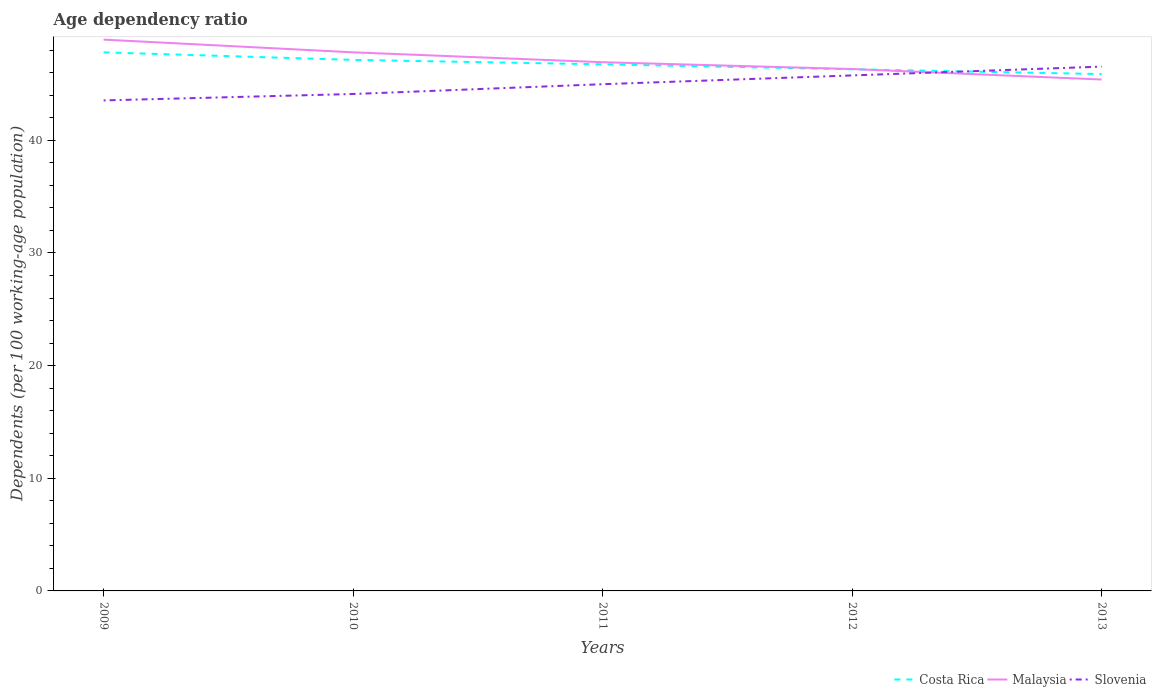Does the line corresponding to Malaysia intersect with the line corresponding to Costa Rica?
Provide a succinct answer. Yes. Across all years, what is the maximum age dependency ratio in in Costa Rica?
Give a very brief answer. 45.88. What is the total age dependency ratio in in Costa Rica in the graph?
Offer a very short reply. 0.43. What is the difference between the highest and the second highest age dependency ratio in in Costa Rica?
Ensure brevity in your answer.  1.93. Are the values on the major ticks of Y-axis written in scientific E-notation?
Make the answer very short. No. Does the graph contain any zero values?
Give a very brief answer. No. Where does the legend appear in the graph?
Provide a succinct answer. Bottom right. How are the legend labels stacked?
Give a very brief answer. Horizontal. What is the title of the graph?
Offer a very short reply. Age dependency ratio. Does "French Polynesia" appear as one of the legend labels in the graph?
Ensure brevity in your answer.  No. What is the label or title of the Y-axis?
Ensure brevity in your answer.  Dependents (per 100 working-age population). What is the Dependents (per 100 working-age population) in Costa Rica in 2009?
Keep it short and to the point. 47.81. What is the Dependents (per 100 working-age population) of Malaysia in 2009?
Your response must be concise. 48.94. What is the Dependents (per 100 working-age population) in Slovenia in 2009?
Keep it short and to the point. 43.54. What is the Dependents (per 100 working-age population) in Costa Rica in 2010?
Offer a very short reply. 47.14. What is the Dependents (per 100 working-age population) in Malaysia in 2010?
Your response must be concise. 47.81. What is the Dependents (per 100 working-age population) of Slovenia in 2010?
Your answer should be very brief. 44.11. What is the Dependents (per 100 working-age population) in Costa Rica in 2011?
Make the answer very short. 46.75. What is the Dependents (per 100 working-age population) in Malaysia in 2011?
Your answer should be compact. 46.93. What is the Dependents (per 100 working-age population) of Slovenia in 2011?
Offer a terse response. 44.98. What is the Dependents (per 100 working-age population) of Costa Rica in 2012?
Provide a succinct answer. 46.31. What is the Dependents (per 100 working-age population) of Malaysia in 2012?
Give a very brief answer. 46.33. What is the Dependents (per 100 working-age population) of Slovenia in 2012?
Provide a succinct answer. 45.76. What is the Dependents (per 100 working-age population) in Costa Rica in 2013?
Your response must be concise. 45.88. What is the Dependents (per 100 working-age population) of Malaysia in 2013?
Offer a terse response. 45.4. What is the Dependents (per 100 working-age population) in Slovenia in 2013?
Your answer should be very brief. 46.54. Across all years, what is the maximum Dependents (per 100 working-age population) in Costa Rica?
Your answer should be very brief. 47.81. Across all years, what is the maximum Dependents (per 100 working-age population) in Malaysia?
Ensure brevity in your answer.  48.94. Across all years, what is the maximum Dependents (per 100 working-age population) in Slovenia?
Your response must be concise. 46.54. Across all years, what is the minimum Dependents (per 100 working-age population) of Costa Rica?
Make the answer very short. 45.88. Across all years, what is the minimum Dependents (per 100 working-age population) of Malaysia?
Offer a terse response. 45.4. Across all years, what is the minimum Dependents (per 100 working-age population) of Slovenia?
Offer a terse response. 43.54. What is the total Dependents (per 100 working-age population) in Costa Rica in the graph?
Ensure brevity in your answer.  233.88. What is the total Dependents (per 100 working-age population) in Malaysia in the graph?
Ensure brevity in your answer.  235.4. What is the total Dependents (per 100 working-age population) of Slovenia in the graph?
Your answer should be very brief. 224.93. What is the difference between the Dependents (per 100 working-age population) of Costa Rica in 2009 and that in 2010?
Provide a succinct answer. 0.67. What is the difference between the Dependents (per 100 working-age population) of Malaysia in 2009 and that in 2010?
Your answer should be very brief. 1.13. What is the difference between the Dependents (per 100 working-age population) of Slovenia in 2009 and that in 2010?
Keep it short and to the point. -0.57. What is the difference between the Dependents (per 100 working-age population) in Costa Rica in 2009 and that in 2011?
Provide a succinct answer. 1.06. What is the difference between the Dependents (per 100 working-age population) of Malaysia in 2009 and that in 2011?
Keep it short and to the point. 2. What is the difference between the Dependents (per 100 working-age population) in Slovenia in 2009 and that in 2011?
Offer a terse response. -1.44. What is the difference between the Dependents (per 100 working-age population) in Costa Rica in 2009 and that in 2012?
Your response must be concise. 1.5. What is the difference between the Dependents (per 100 working-age population) of Malaysia in 2009 and that in 2012?
Ensure brevity in your answer.  2.61. What is the difference between the Dependents (per 100 working-age population) in Slovenia in 2009 and that in 2012?
Make the answer very short. -2.22. What is the difference between the Dependents (per 100 working-age population) in Costa Rica in 2009 and that in 2013?
Offer a terse response. 1.93. What is the difference between the Dependents (per 100 working-age population) of Malaysia in 2009 and that in 2013?
Your answer should be compact. 3.54. What is the difference between the Dependents (per 100 working-age population) of Slovenia in 2009 and that in 2013?
Provide a short and direct response. -3. What is the difference between the Dependents (per 100 working-age population) in Costa Rica in 2010 and that in 2011?
Make the answer very short. 0.39. What is the difference between the Dependents (per 100 working-age population) in Malaysia in 2010 and that in 2011?
Offer a terse response. 0.88. What is the difference between the Dependents (per 100 working-age population) of Slovenia in 2010 and that in 2011?
Provide a short and direct response. -0.87. What is the difference between the Dependents (per 100 working-age population) of Costa Rica in 2010 and that in 2012?
Give a very brief answer. 0.83. What is the difference between the Dependents (per 100 working-age population) of Malaysia in 2010 and that in 2012?
Your answer should be compact. 1.48. What is the difference between the Dependents (per 100 working-age population) in Slovenia in 2010 and that in 2012?
Offer a terse response. -1.65. What is the difference between the Dependents (per 100 working-age population) of Costa Rica in 2010 and that in 2013?
Your response must be concise. 1.26. What is the difference between the Dependents (per 100 working-age population) in Malaysia in 2010 and that in 2013?
Provide a short and direct response. 2.41. What is the difference between the Dependents (per 100 working-age population) in Slovenia in 2010 and that in 2013?
Offer a terse response. -2.43. What is the difference between the Dependents (per 100 working-age population) in Costa Rica in 2011 and that in 2012?
Offer a terse response. 0.44. What is the difference between the Dependents (per 100 working-age population) of Malaysia in 2011 and that in 2012?
Make the answer very short. 0.61. What is the difference between the Dependents (per 100 working-age population) of Slovenia in 2011 and that in 2012?
Offer a very short reply. -0.78. What is the difference between the Dependents (per 100 working-age population) in Costa Rica in 2011 and that in 2013?
Provide a succinct answer. 0.87. What is the difference between the Dependents (per 100 working-age population) in Malaysia in 2011 and that in 2013?
Keep it short and to the point. 1.54. What is the difference between the Dependents (per 100 working-age population) of Slovenia in 2011 and that in 2013?
Ensure brevity in your answer.  -1.56. What is the difference between the Dependents (per 100 working-age population) of Costa Rica in 2012 and that in 2013?
Ensure brevity in your answer.  0.43. What is the difference between the Dependents (per 100 working-age population) of Malaysia in 2012 and that in 2013?
Make the answer very short. 0.93. What is the difference between the Dependents (per 100 working-age population) of Slovenia in 2012 and that in 2013?
Provide a succinct answer. -0.78. What is the difference between the Dependents (per 100 working-age population) of Costa Rica in 2009 and the Dependents (per 100 working-age population) of Malaysia in 2010?
Your answer should be very brief. -0. What is the difference between the Dependents (per 100 working-age population) in Costa Rica in 2009 and the Dependents (per 100 working-age population) in Slovenia in 2010?
Provide a succinct answer. 3.7. What is the difference between the Dependents (per 100 working-age population) of Malaysia in 2009 and the Dependents (per 100 working-age population) of Slovenia in 2010?
Your answer should be compact. 4.83. What is the difference between the Dependents (per 100 working-age population) in Costa Rica in 2009 and the Dependents (per 100 working-age population) in Malaysia in 2011?
Offer a very short reply. 0.88. What is the difference between the Dependents (per 100 working-age population) of Costa Rica in 2009 and the Dependents (per 100 working-age population) of Slovenia in 2011?
Your response must be concise. 2.83. What is the difference between the Dependents (per 100 working-age population) of Malaysia in 2009 and the Dependents (per 100 working-age population) of Slovenia in 2011?
Your response must be concise. 3.96. What is the difference between the Dependents (per 100 working-age population) in Costa Rica in 2009 and the Dependents (per 100 working-age population) in Malaysia in 2012?
Your answer should be very brief. 1.48. What is the difference between the Dependents (per 100 working-age population) in Costa Rica in 2009 and the Dependents (per 100 working-age population) in Slovenia in 2012?
Provide a short and direct response. 2.05. What is the difference between the Dependents (per 100 working-age population) in Malaysia in 2009 and the Dependents (per 100 working-age population) in Slovenia in 2012?
Offer a terse response. 3.18. What is the difference between the Dependents (per 100 working-age population) of Costa Rica in 2009 and the Dependents (per 100 working-age population) of Malaysia in 2013?
Ensure brevity in your answer.  2.41. What is the difference between the Dependents (per 100 working-age population) in Costa Rica in 2009 and the Dependents (per 100 working-age population) in Slovenia in 2013?
Your response must be concise. 1.27. What is the difference between the Dependents (per 100 working-age population) of Malaysia in 2009 and the Dependents (per 100 working-age population) of Slovenia in 2013?
Provide a short and direct response. 2.4. What is the difference between the Dependents (per 100 working-age population) of Costa Rica in 2010 and the Dependents (per 100 working-age population) of Malaysia in 2011?
Provide a short and direct response. 0.21. What is the difference between the Dependents (per 100 working-age population) of Costa Rica in 2010 and the Dependents (per 100 working-age population) of Slovenia in 2011?
Give a very brief answer. 2.16. What is the difference between the Dependents (per 100 working-age population) in Malaysia in 2010 and the Dependents (per 100 working-age population) in Slovenia in 2011?
Offer a terse response. 2.83. What is the difference between the Dependents (per 100 working-age population) in Costa Rica in 2010 and the Dependents (per 100 working-age population) in Malaysia in 2012?
Your answer should be compact. 0.81. What is the difference between the Dependents (per 100 working-age population) in Costa Rica in 2010 and the Dependents (per 100 working-age population) in Slovenia in 2012?
Your answer should be very brief. 1.38. What is the difference between the Dependents (per 100 working-age population) of Malaysia in 2010 and the Dependents (per 100 working-age population) of Slovenia in 2012?
Offer a terse response. 2.05. What is the difference between the Dependents (per 100 working-age population) of Costa Rica in 2010 and the Dependents (per 100 working-age population) of Malaysia in 2013?
Provide a short and direct response. 1.74. What is the difference between the Dependents (per 100 working-age population) of Costa Rica in 2010 and the Dependents (per 100 working-age population) of Slovenia in 2013?
Your answer should be compact. 0.6. What is the difference between the Dependents (per 100 working-age population) of Malaysia in 2010 and the Dependents (per 100 working-age population) of Slovenia in 2013?
Make the answer very short. 1.27. What is the difference between the Dependents (per 100 working-age population) of Costa Rica in 2011 and the Dependents (per 100 working-age population) of Malaysia in 2012?
Offer a very short reply. 0.42. What is the difference between the Dependents (per 100 working-age population) of Costa Rica in 2011 and the Dependents (per 100 working-age population) of Slovenia in 2012?
Your answer should be compact. 0.99. What is the difference between the Dependents (per 100 working-age population) in Malaysia in 2011 and the Dependents (per 100 working-age population) in Slovenia in 2012?
Your answer should be very brief. 1.17. What is the difference between the Dependents (per 100 working-age population) of Costa Rica in 2011 and the Dependents (per 100 working-age population) of Malaysia in 2013?
Offer a terse response. 1.35. What is the difference between the Dependents (per 100 working-age population) of Costa Rica in 2011 and the Dependents (per 100 working-age population) of Slovenia in 2013?
Ensure brevity in your answer.  0.2. What is the difference between the Dependents (per 100 working-age population) in Malaysia in 2011 and the Dependents (per 100 working-age population) in Slovenia in 2013?
Make the answer very short. 0.39. What is the difference between the Dependents (per 100 working-age population) of Costa Rica in 2012 and the Dependents (per 100 working-age population) of Malaysia in 2013?
Offer a very short reply. 0.91. What is the difference between the Dependents (per 100 working-age population) in Costa Rica in 2012 and the Dependents (per 100 working-age population) in Slovenia in 2013?
Your answer should be very brief. -0.24. What is the difference between the Dependents (per 100 working-age population) in Malaysia in 2012 and the Dependents (per 100 working-age population) in Slovenia in 2013?
Ensure brevity in your answer.  -0.21. What is the average Dependents (per 100 working-age population) in Costa Rica per year?
Give a very brief answer. 46.78. What is the average Dependents (per 100 working-age population) of Malaysia per year?
Your answer should be very brief. 47.08. What is the average Dependents (per 100 working-age population) of Slovenia per year?
Your response must be concise. 44.99. In the year 2009, what is the difference between the Dependents (per 100 working-age population) in Costa Rica and Dependents (per 100 working-age population) in Malaysia?
Keep it short and to the point. -1.13. In the year 2009, what is the difference between the Dependents (per 100 working-age population) of Costa Rica and Dependents (per 100 working-age population) of Slovenia?
Offer a very short reply. 4.27. In the year 2009, what is the difference between the Dependents (per 100 working-age population) of Malaysia and Dependents (per 100 working-age population) of Slovenia?
Your answer should be compact. 5.4. In the year 2010, what is the difference between the Dependents (per 100 working-age population) of Costa Rica and Dependents (per 100 working-age population) of Malaysia?
Your answer should be very brief. -0.67. In the year 2010, what is the difference between the Dependents (per 100 working-age population) of Costa Rica and Dependents (per 100 working-age population) of Slovenia?
Provide a succinct answer. 3.03. In the year 2010, what is the difference between the Dependents (per 100 working-age population) of Malaysia and Dependents (per 100 working-age population) of Slovenia?
Your answer should be very brief. 3.7. In the year 2011, what is the difference between the Dependents (per 100 working-age population) in Costa Rica and Dependents (per 100 working-age population) in Malaysia?
Give a very brief answer. -0.19. In the year 2011, what is the difference between the Dependents (per 100 working-age population) in Costa Rica and Dependents (per 100 working-age population) in Slovenia?
Keep it short and to the point. 1.77. In the year 2011, what is the difference between the Dependents (per 100 working-age population) in Malaysia and Dependents (per 100 working-age population) in Slovenia?
Your answer should be very brief. 1.95. In the year 2012, what is the difference between the Dependents (per 100 working-age population) of Costa Rica and Dependents (per 100 working-age population) of Malaysia?
Offer a terse response. -0.02. In the year 2012, what is the difference between the Dependents (per 100 working-age population) in Costa Rica and Dependents (per 100 working-age population) in Slovenia?
Give a very brief answer. 0.55. In the year 2012, what is the difference between the Dependents (per 100 working-age population) of Malaysia and Dependents (per 100 working-age population) of Slovenia?
Make the answer very short. 0.57. In the year 2013, what is the difference between the Dependents (per 100 working-age population) in Costa Rica and Dependents (per 100 working-age population) in Malaysia?
Your response must be concise. 0.48. In the year 2013, what is the difference between the Dependents (per 100 working-age population) of Costa Rica and Dependents (per 100 working-age population) of Slovenia?
Offer a terse response. -0.66. In the year 2013, what is the difference between the Dependents (per 100 working-age population) in Malaysia and Dependents (per 100 working-age population) in Slovenia?
Offer a very short reply. -1.15. What is the ratio of the Dependents (per 100 working-age population) in Costa Rica in 2009 to that in 2010?
Your response must be concise. 1.01. What is the ratio of the Dependents (per 100 working-age population) of Malaysia in 2009 to that in 2010?
Keep it short and to the point. 1.02. What is the ratio of the Dependents (per 100 working-age population) in Slovenia in 2009 to that in 2010?
Give a very brief answer. 0.99. What is the ratio of the Dependents (per 100 working-age population) of Costa Rica in 2009 to that in 2011?
Make the answer very short. 1.02. What is the ratio of the Dependents (per 100 working-age population) of Malaysia in 2009 to that in 2011?
Give a very brief answer. 1.04. What is the ratio of the Dependents (per 100 working-age population) of Costa Rica in 2009 to that in 2012?
Ensure brevity in your answer.  1.03. What is the ratio of the Dependents (per 100 working-age population) in Malaysia in 2009 to that in 2012?
Your answer should be very brief. 1.06. What is the ratio of the Dependents (per 100 working-age population) in Slovenia in 2009 to that in 2012?
Offer a terse response. 0.95. What is the ratio of the Dependents (per 100 working-age population) of Costa Rica in 2009 to that in 2013?
Your response must be concise. 1.04. What is the ratio of the Dependents (per 100 working-age population) of Malaysia in 2009 to that in 2013?
Your response must be concise. 1.08. What is the ratio of the Dependents (per 100 working-age population) in Slovenia in 2009 to that in 2013?
Offer a terse response. 0.94. What is the ratio of the Dependents (per 100 working-age population) of Costa Rica in 2010 to that in 2011?
Provide a short and direct response. 1.01. What is the ratio of the Dependents (per 100 working-age population) in Malaysia in 2010 to that in 2011?
Provide a short and direct response. 1.02. What is the ratio of the Dependents (per 100 working-age population) in Slovenia in 2010 to that in 2011?
Ensure brevity in your answer.  0.98. What is the ratio of the Dependents (per 100 working-age population) of Costa Rica in 2010 to that in 2012?
Give a very brief answer. 1.02. What is the ratio of the Dependents (per 100 working-age population) of Malaysia in 2010 to that in 2012?
Provide a short and direct response. 1.03. What is the ratio of the Dependents (per 100 working-age population) in Slovenia in 2010 to that in 2012?
Give a very brief answer. 0.96. What is the ratio of the Dependents (per 100 working-age population) in Costa Rica in 2010 to that in 2013?
Offer a terse response. 1.03. What is the ratio of the Dependents (per 100 working-age population) of Malaysia in 2010 to that in 2013?
Offer a very short reply. 1.05. What is the ratio of the Dependents (per 100 working-age population) of Slovenia in 2010 to that in 2013?
Keep it short and to the point. 0.95. What is the ratio of the Dependents (per 100 working-age population) of Costa Rica in 2011 to that in 2012?
Offer a terse response. 1.01. What is the ratio of the Dependents (per 100 working-age population) in Malaysia in 2011 to that in 2012?
Give a very brief answer. 1.01. What is the ratio of the Dependents (per 100 working-age population) in Slovenia in 2011 to that in 2012?
Your answer should be very brief. 0.98. What is the ratio of the Dependents (per 100 working-age population) in Costa Rica in 2011 to that in 2013?
Make the answer very short. 1.02. What is the ratio of the Dependents (per 100 working-age population) of Malaysia in 2011 to that in 2013?
Your response must be concise. 1.03. What is the ratio of the Dependents (per 100 working-age population) in Slovenia in 2011 to that in 2013?
Your answer should be very brief. 0.97. What is the ratio of the Dependents (per 100 working-age population) of Costa Rica in 2012 to that in 2013?
Your response must be concise. 1.01. What is the ratio of the Dependents (per 100 working-age population) in Malaysia in 2012 to that in 2013?
Your answer should be very brief. 1.02. What is the ratio of the Dependents (per 100 working-age population) of Slovenia in 2012 to that in 2013?
Provide a short and direct response. 0.98. What is the difference between the highest and the second highest Dependents (per 100 working-age population) of Costa Rica?
Ensure brevity in your answer.  0.67. What is the difference between the highest and the second highest Dependents (per 100 working-age population) of Malaysia?
Your response must be concise. 1.13. What is the difference between the highest and the second highest Dependents (per 100 working-age population) of Slovenia?
Provide a short and direct response. 0.78. What is the difference between the highest and the lowest Dependents (per 100 working-age population) in Costa Rica?
Give a very brief answer. 1.93. What is the difference between the highest and the lowest Dependents (per 100 working-age population) in Malaysia?
Make the answer very short. 3.54. What is the difference between the highest and the lowest Dependents (per 100 working-age population) in Slovenia?
Your answer should be very brief. 3. 